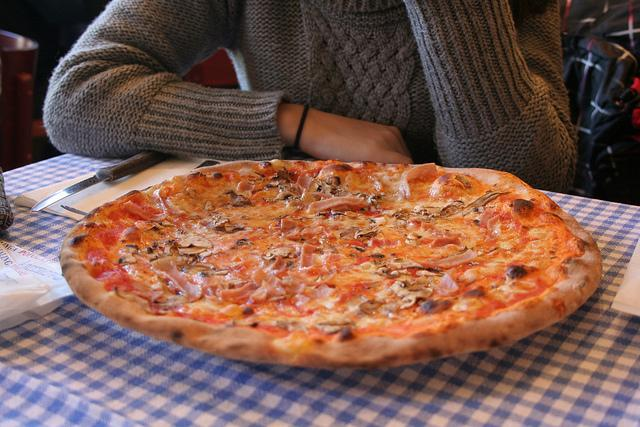How many distinct topping types are on this pizza? Please explain your reasoning. two. There is ham and mushrooms 